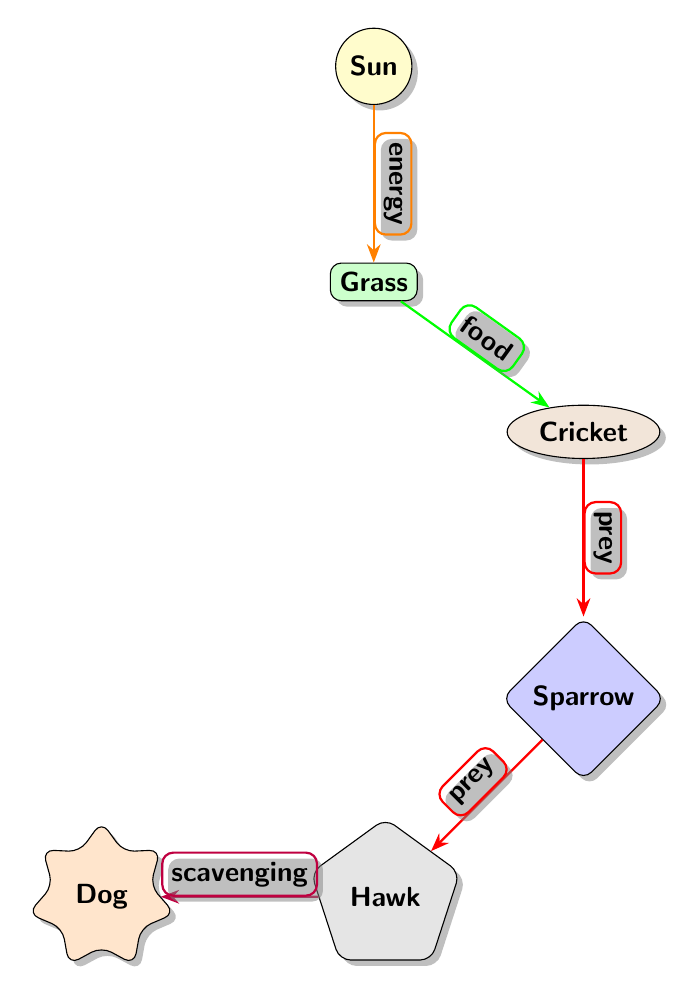What is the top node in the food chain? The top node represents the primary energy source in the food chain. By examining the diagram, the first node at the top is labeled "Sun."
Answer: Sun How many nodes are in the food chain? To find the total number of nodes, count each distinct entity in the diagram: Sun, Grass, Cricket, Sparrow, Hawk, Dog. This totals to six.
Answer: 6 What type of animal is directly above the "Sparrow"? The "Sparrow" is connected upward to another node labeled "Hawk." Thus, the type of animal above it is a Hawk.
Answer: Hawk What is the relationship between "Grass" and "Cricket"? The diagram indicates that "Grass" provides "food" for "Cricket," which establishes a direct food relationship.
Answer: food Which node represents a scavenger in the food chain? By analyzing the arrows and the relationships, the node labeled "Dog" is shown to be connected to the "Hawk," indicating it acts as a scavenger.
Answer: Dog What does the "Hawk" primarily prey on? Following the arrows from the "Hawk" downward in the chain, the "Hawk" preys on the "Sparrow."
Answer: Sparrow In terms of energy, what flows from the "Sun" to "Grass"? The diagram specifies that energy flows from the "Sun" to the "Grass," representing the energy transfer within the food chain.
Answer: energy What color is the "Cricket" node? A quick inspection of the diagram shows that the node marked for "Cricket" is filled with a color coded as brown.
Answer: brown 